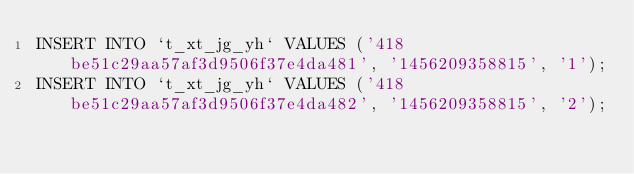<code> <loc_0><loc_0><loc_500><loc_500><_SQL_>INSERT INTO `t_xt_jg_yh` VALUES ('418be51c29aa57af3d9506f37e4da481', '1456209358815', '1');
INSERT INTO `t_xt_jg_yh` VALUES ('418be51c29aa57af3d9506f37e4da482', '1456209358815', '2');

</code> 